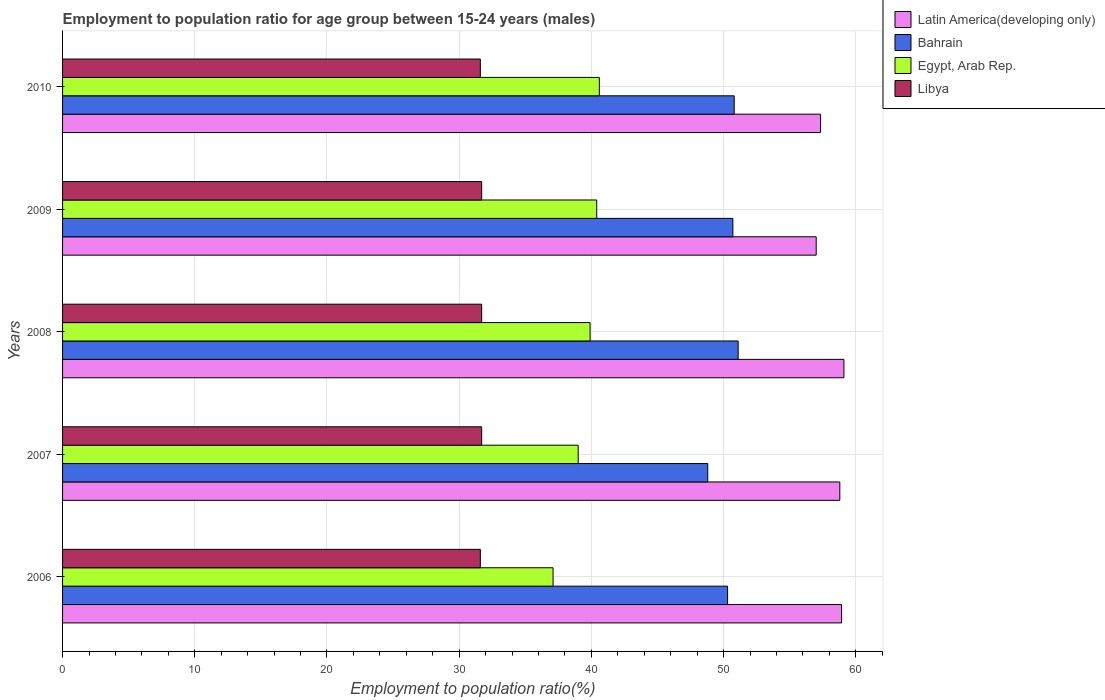How many different coloured bars are there?
Make the answer very short. 4. How many groups of bars are there?
Provide a succinct answer. 5. Are the number of bars per tick equal to the number of legend labels?
Offer a very short reply. Yes. What is the label of the 1st group of bars from the top?
Ensure brevity in your answer.  2010. In how many cases, is the number of bars for a given year not equal to the number of legend labels?
Make the answer very short. 0. What is the employment to population ratio in Latin America(developing only) in 2006?
Your response must be concise. 58.92. Across all years, what is the maximum employment to population ratio in Latin America(developing only)?
Provide a short and direct response. 59.1. Across all years, what is the minimum employment to population ratio in Libya?
Your answer should be compact. 31.6. What is the total employment to population ratio in Libya in the graph?
Your answer should be very brief. 158.3. What is the difference between the employment to population ratio in Bahrain in 2007 and that in 2008?
Keep it short and to the point. -2.3. What is the difference between the employment to population ratio in Egypt, Arab Rep. in 2006 and the employment to population ratio in Libya in 2007?
Offer a terse response. 5.4. What is the average employment to population ratio in Bahrain per year?
Make the answer very short. 50.34. In the year 2010, what is the difference between the employment to population ratio in Egypt, Arab Rep. and employment to population ratio in Bahrain?
Your answer should be very brief. -10.2. In how many years, is the employment to population ratio in Egypt, Arab Rep. greater than 12 %?
Offer a terse response. 5. What is the ratio of the employment to population ratio in Latin America(developing only) in 2009 to that in 2010?
Your response must be concise. 0.99. Is the employment to population ratio in Bahrain in 2006 less than that in 2008?
Your answer should be compact. Yes. Is the difference between the employment to population ratio in Egypt, Arab Rep. in 2006 and 2008 greater than the difference between the employment to population ratio in Bahrain in 2006 and 2008?
Provide a succinct answer. No. What is the difference between the highest and the second highest employment to population ratio in Bahrain?
Provide a short and direct response. 0.3. What is the difference between the highest and the lowest employment to population ratio in Bahrain?
Make the answer very short. 2.3. In how many years, is the employment to population ratio in Egypt, Arab Rep. greater than the average employment to population ratio in Egypt, Arab Rep. taken over all years?
Your answer should be very brief. 3. What does the 2nd bar from the top in 2006 represents?
Make the answer very short. Egypt, Arab Rep. What does the 2nd bar from the bottom in 2007 represents?
Ensure brevity in your answer.  Bahrain. How many bars are there?
Your answer should be very brief. 20. Are all the bars in the graph horizontal?
Your response must be concise. Yes. Are the values on the major ticks of X-axis written in scientific E-notation?
Keep it short and to the point. No. Does the graph contain any zero values?
Offer a terse response. No. Does the graph contain grids?
Your response must be concise. Yes. How many legend labels are there?
Make the answer very short. 4. How are the legend labels stacked?
Provide a succinct answer. Vertical. What is the title of the graph?
Provide a succinct answer. Employment to population ratio for age group between 15-24 years (males). Does "Portugal" appear as one of the legend labels in the graph?
Your response must be concise. No. What is the label or title of the X-axis?
Provide a succinct answer. Employment to population ratio(%). What is the Employment to population ratio(%) in Latin America(developing only) in 2006?
Make the answer very short. 58.92. What is the Employment to population ratio(%) in Bahrain in 2006?
Provide a short and direct response. 50.3. What is the Employment to population ratio(%) of Egypt, Arab Rep. in 2006?
Your answer should be very brief. 37.1. What is the Employment to population ratio(%) of Libya in 2006?
Ensure brevity in your answer.  31.6. What is the Employment to population ratio(%) in Latin America(developing only) in 2007?
Your answer should be very brief. 58.79. What is the Employment to population ratio(%) in Bahrain in 2007?
Offer a very short reply. 48.8. What is the Employment to population ratio(%) of Libya in 2007?
Offer a terse response. 31.7. What is the Employment to population ratio(%) of Latin America(developing only) in 2008?
Give a very brief answer. 59.1. What is the Employment to population ratio(%) in Bahrain in 2008?
Your response must be concise. 51.1. What is the Employment to population ratio(%) of Egypt, Arab Rep. in 2008?
Offer a very short reply. 39.9. What is the Employment to population ratio(%) of Libya in 2008?
Offer a very short reply. 31.7. What is the Employment to population ratio(%) of Latin America(developing only) in 2009?
Keep it short and to the point. 57. What is the Employment to population ratio(%) of Bahrain in 2009?
Provide a short and direct response. 50.7. What is the Employment to population ratio(%) in Egypt, Arab Rep. in 2009?
Offer a very short reply. 40.4. What is the Employment to population ratio(%) in Libya in 2009?
Keep it short and to the point. 31.7. What is the Employment to population ratio(%) of Latin America(developing only) in 2010?
Offer a terse response. 57.33. What is the Employment to population ratio(%) in Bahrain in 2010?
Your response must be concise. 50.8. What is the Employment to population ratio(%) of Egypt, Arab Rep. in 2010?
Ensure brevity in your answer.  40.6. What is the Employment to population ratio(%) in Libya in 2010?
Provide a succinct answer. 31.6. Across all years, what is the maximum Employment to population ratio(%) of Latin America(developing only)?
Keep it short and to the point. 59.1. Across all years, what is the maximum Employment to population ratio(%) in Bahrain?
Make the answer very short. 51.1. Across all years, what is the maximum Employment to population ratio(%) of Egypt, Arab Rep.?
Provide a short and direct response. 40.6. Across all years, what is the maximum Employment to population ratio(%) in Libya?
Offer a very short reply. 31.7. Across all years, what is the minimum Employment to population ratio(%) in Latin America(developing only)?
Your answer should be very brief. 57. Across all years, what is the minimum Employment to population ratio(%) in Bahrain?
Give a very brief answer. 48.8. Across all years, what is the minimum Employment to population ratio(%) in Egypt, Arab Rep.?
Make the answer very short. 37.1. Across all years, what is the minimum Employment to population ratio(%) of Libya?
Give a very brief answer. 31.6. What is the total Employment to population ratio(%) in Latin America(developing only) in the graph?
Provide a short and direct response. 291.14. What is the total Employment to population ratio(%) in Bahrain in the graph?
Make the answer very short. 251.7. What is the total Employment to population ratio(%) in Egypt, Arab Rep. in the graph?
Your response must be concise. 197. What is the total Employment to population ratio(%) of Libya in the graph?
Give a very brief answer. 158.3. What is the difference between the Employment to population ratio(%) in Latin America(developing only) in 2006 and that in 2007?
Your response must be concise. 0.13. What is the difference between the Employment to population ratio(%) of Latin America(developing only) in 2006 and that in 2008?
Your answer should be compact. -0.18. What is the difference between the Employment to population ratio(%) in Libya in 2006 and that in 2008?
Your response must be concise. -0.1. What is the difference between the Employment to population ratio(%) of Latin America(developing only) in 2006 and that in 2009?
Offer a very short reply. 1.92. What is the difference between the Employment to population ratio(%) of Bahrain in 2006 and that in 2009?
Provide a succinct answer. -0.4. What is the difference between the Employment to population ratio(%) of Latin America(developing only) in 2006 and that in 2010?
Offer a terse response. 1.59. What is the difference between the Employment to population ratio(%) in Libya in 2006 and that in 2010?
Provide a succinct answer. 0. What is the difference between the Employment to population ratio(%) in Latin America(developing only) in 2007 and that in 2008?
Make the answer very short. -0.31. What is the difference between the Employment to population ratio(%) of Latin America(developing only) in 2007 and that in 2009?
Make the answer very short. 1.79. What is the difference between the Employment to population ratio(%) of Egypt, Arab Rep. in 2007 and that in 2009?
Give a very brief answer. -1.4. What is the difference between the Employment to population ratio(%) in Libya in 2007 and that in 2009?
Provide a short and direct response. 0. What is the difference between the Employment to population ratio(%) of Latin America(developing only) in 2007 and that in 2010?
Your response must be concise. 1.46. What is the difference between the Employment to population ratio(%) of Libya in 2007 and that in 2010?
Provide a succinct answer. 0.1. What is the difference between the Employment to population ratio(%) in Latin America(developing only) in 2008 and that in 2009?
Ensure brevity in your answer.  2.1. What is the difference between the Employment to population ratio(%) in Egypt, Arab Rep. in 2008 and that in 2009?
Your response must be concise. -0.5. What is the difference between the Employment to population ratio(%) of Libya in 2008 and that in 2009?
Offer a very short reply. 0. What is the difference between the Employment to population ratio(%) of Latin America(developing only) in 2008 and that in 2010?
Make the answer very short. 1.77. What is the difference between the Employment to population ratio(%) of Latin America(developing only) in 2009 and that in 2010?
Your answer should be compact. -0.33. What is the difference between the Employment to population ratio(%) of Bahrain in 2009 and that in 2010?
Offer a very short reply. -0.1. What is the difference between the Employment to population ratio(%) in Egypt, Arab Rep. in 2009 and that in 2010?
Give a very brief answer. -0.2. What is the difference between the Employment to population ratio(%) in Libya in 2009 and that in 2010?
Offer a terse response. 0.1. What is the difference between the Employment to population ratio(%) in Latin America(developing only) in 2006 and the Employment to population ratio(%) in Bahrain in 2007?
Make the answer very short. 10.12. What is the difference between the Employment to population ratio(%) of Latin America(developing only) in 2006 and the Employment to population ratio(%) of Egypt, Arab Rep. in 2007?
Your answer should be very brief. 19.92. What is the difference between the Employment to population ratio(%) of Latin America(developing only) in 2006 and the Employment to population ratio(%) of Libya in 2007?
Your response must be concise. 27.22. What is the difference between the Employment to population ratio(%) of Bahrain in 2006 and the Employment to population ratio(%) of Egypt, Arab Rep. in 2007?
Keep it short and to the point. 11.3. What is the difference between the Employment to population ratio(%) in Bahrain in 2006 and the Employment to population ratio(%) in Libya in 2007?
Your response must be concise. 18.6. What is the difference between the Employment to population ratio(%) of Egypt, Arab Rep. in 2006 and the Employment to population ratio(%) of Libya in 2007?
Give a very brief answer. 5.4. What is the difference between the Employment to population ratio(%) of Latin America(developing only) in 2006 and the Employment to population ratio(%) of Bahrain in 2008?
Make the answer very short. 7.82. What is the difference between the Employment to population ratio(%) in Latin America(developing only) in 2006 and the Employment to population ratio(%) in Egypt, Arab Rep. in 2008?
Provide a short and direct response. 19.02. What is the difference between the Employment to population ratio(%) of Latin America(developing only) in 2006 and the Employment to population ratio(%) of Libya in 2008?
Provide a short and direct response. 27.22. What is the difference between the Employment to population ratio(%) in Bahrain in 2006 and the Employment to population ratio(%) in Egypt, Arab Rep. in 2008?
Offer a terse response. 10.4. What is the difference between the Employment to population ratio(%) of Bahrain in 2006 and the Employment to population ratio(%) of Libya in 2008?
Provide a succinct answer. 18.6. What is the difference between the Employment to population ratio(%) of Latin America(developing only) in 2006 and the Employment to population ratio(%) of Bahrain in 2009?
Give a very brief answer. 8.22. What is the difference between the Employment to population ratio(%) in Latin America(developing only) in 2006 and the Employment to population ratio(%) in Egypt, Arab Rep. in 2009?
Offer a very short reply. 18.52. What is the difference between the Employment to population ratio(%) in Latin America(developing only) in 2006 and the Employment to population ratio(%) in Libya in 2009?
Make the answer very short. 27.22. What is the difference between the Employment to population ratio(%) in Bahrain in 2006 and the Employment to population ratio(%) in Egypt, Arab Rep. in 2009?
Your answer should be compact. 9.9. What is the difference between the Employment to population ratio(%) of Latin America(developing only) in 2006 and the Employment to population ratio(%) of Bahrain in 2010?
Provide a short and direct response. 8.12. What is the difference between the Employment to population ratio(%) in Latin America(developing only) in 2006 and the Employment to population ratio(%) in Egypt, Arab Rep. in 2010?
Provide a succinct answer. 18.32. What is the difference between the Employment to population ratio(%) in Latin America(developing only) in 2006 and the Employment to population ratio(%) in Libya in 2010?
Your response must be concise. 27.32. What is the difference between the Employment to population ratio(%) in Bahrain in 2006 and the Employment to population ratio(%) in Egypt, Arab Rep. in 2010?
Offer a terse response. 9.7. What is the difference between the Employment to population ratio(%) in Bahrain in 2006 and the Employment to population ratio(%) in Libya in 2010?
Make the answer very short. 18.7. What is the difference between the Employment to population ratio(%) of Latin America(developing only) in 2007 and the Employment to population ratio(%) of Bahrain in 2008?
Make the answer very short. 7.69. What is the difference between the Employment to population ratio(%) of Latin America(developing only) in 2007 and the Employment to population ratio(%) of Egypt, Arab Rep. in 2008?
Provide a short and direct response. 18.89. What is the difference between the Employment to population ratio(%) of Latin America(developing only) in 2007 and the Employment to population ratio(%) of Libya in 2008?
Offer a terse response. 27.09. What is the difference between the Employment to population ratio(%) in Bahrain in 2007 and the Employment to population ratio(%) in Libya in 2008?
Provide a short and direct response. 17.1. What is the difference between the Employment to population ratio(%) in Latin America(developing only) in 2007 and the Employment to population ratio(%) in Bahrain in 2009?
Offer a terse response. 8.09. What is the difference between the Employment to population ratio(%) of Latin America(developing only) in 2007 and the Employment to population ratio(%) of Egypt, Arab Rep. in 2009?
Offer a very short reply. 18.39. What is the difference between the Employment to population ratio(%) in Latin America(developing only) in 2007 and the Employment to population ratio(%) in Libya in 2009?
Your answer should be compact. 27.09. What is the difference between the Employment to population ratio(%) of Bahrain in 2007 and the Employment to population ratio(%) of Egypt, Arab Rep. in 2009?
Your answer should be very brief. 8.4. What is the difference between the Employment to population ratio(%) in Latin America(developing only) in 2007 and the Employment to population ratio(%) in Bahrain in 2010?
Provide a short and direct response. 7.99. What is the difference between the Employment to population ratio(%) of Latin America(developing only) in 2007 and the Employment to population ratio(%) of Egypt, Arab Rep. in 2010?
Provide a short and direct response. 18.19. What is the difference between the Employment to population ratio(%) in Latin America(developing only) in 2007 and the Employment to population ratio(%) in Libya in 2010?
Your response must be concise. 27.19. What is the difference between the Employment to population ratio(%) in Bahrain in 2007 and the Employment to population ratio(%) in Libya in 2010?
Provide a succinct answer. 17.2. What is the difference between the Employment to population ratio(%) in Latin America(developing only) in 2008 and the Employment to population ratio(%) in Bahrain in 2009?
Offer a very short reply. 8.4. What is the difference between the Employment to population ratio(%) in Latin America(developing only) in 2008 and the Employment to population ratio(%) in Egypt, Arab Rep. in 2009?
Provide a succinct answer. 18.7. What is the difference between the Employment to population ratio(%) of Latin America(developing only) in 2008 and the Employment to population ratio(%) of Libya in 2009?
Ensure brevity in your answer.  27.4. What is the difference between the Employment to population ratio(%) of Bahrain in 2008 and the Employment to population ratio(%) of Egypt, Arab Rep. in 2009?
Offer a terse response. 10.7. What is the difference between the Employment to population ratio(%) in Bahrain in 2008 and the Employment to population ratio(%) in Libya in 2009?
Give a very brief answer. 19.4. What is the difference between the Employment to population ratio(%) in Egypt, Arab Rep. in 2008 and the Employment to population ratio(%) in Libya in 2009?
Your answer should be very brief. 8.2. What is the difference between the Employment to population ratio(%) of Latin America(developing only) in 2008 and the Employment to population ratio(%) of Bahrain in 2010?
Provide a succinct answer. 8.3. What is the difference between the Employment to population ratio(%) of Latin America(developing only) in 2008 and the Employment to population ratio(%) of Egypt, Arab Rep. in 2010?
Keep it short and to the point. 18.5. What is the difference between the Employment to population ratio(%) of Latin America(developing only) in 2008 and the Employment to population ratio(%) of Libya in 2010?
Make the answer very short. 27.5. What is the difference between the Employment to population ratio(%) in Egypt, Arab Rep. in 2008 and the Employment to population ratio(%) in Libya in 2010?
Offer a very short reply. 8.3. What is the difference between the Employment to population ratio(%) of Latin America(developing only) in 2009 and the Employment to population ratio(%) of Bahrain in 2010?
Make the answer very short. 6.2. What is the difference between the Employment to population ratio(%) of Latin America(developing only) in 2009 and the Employment to population ratio(%) of Egypt, Arab Rep. in 2010?
Ensure brevity in your answer.  16.4. What is the difference between the Employment to population ratio(%) of Latin America(developing only) in 2009 and the Employment to population ratio(%) of Libya in 2010?
Give a very brief answer. 25.4. What is the difference between the Employment to population ratio(%) of Bahrain in 2009 and the Employment to population ratio(%) of Egypt, Arab Rep. in 2010?
Offer a terse response. 10.1. What is the difference between the Employment to population ratio(%) of Bahrain in 2009 and the Employment to population ratio(%) of Libya in 2010?
Your response must be concise. 19.1. What is the difference between the Employment to population ratio(%) of Egypt, Arab Rep. in 2009 and the Employment to population ratio(%) of Libya in 2010?
Your response must be concise. 8.8. What is the average Employment to population ratio(%) in Latin America(developing only) per year?
Make the answer very short. 58.23. What is the average Employment to population ratio(%) of Bahrain per year?
Provide a succinct answer. 50.34. What is the average Employment to population ratio(%) of Egypt, Arab Rep. per year?
Provide a succinct answer. 39.4. What is the average Employment to population ratio(%) in Libya per year?
Give a very brief answer. 31.66. In the year 2006, what is the difference between the Employment to population ratio(%) in Latin America(developing only) and Employment to population ratio(%) in Bahrain?
Offer a very short reply. 8.62. In the year 2006, what is the difference between the Employment to population ratio(%) in Latin America(developing only) and Employment to population ratio(%) in Egypt, Arab Rep.?
Keep it short and to the point. 21.82. In the year 2006, what is the difference between the Employment to population ratio(%) of Latin America(developing only) and Employment to population ratio(%) of Libya?
Your answer should be compact. 27.32. In the year 2007, what is the difference between the Employment to population ratio(%) of Latin America(developing only) and Employment to population ratio(%) of Bahrain?
Your response must be concise. 9.99. In the year 2007, what is the difference between the Employment to population ratio(%) in Latin America(developing only) and Employment to population ratio(%) in Egypt, Arab Rep.?
Your answer should be compact. 19.79. In the year 2007, what is the difference between the Employment to population ratio(%) of Latin America(developing only) and Employment to population ratio(%) of Libya?
Your answer should be compact. 27.09. In the year 2007, what is the difference between the Employment to population ratio(%) in Bahrain and Employment to population ratio(%) in Egypt, Arab Rep.?
Ensure brevity in your answer.  9.8. In the year 2008, what is the difference between the Employment to population ratio(%) of Latin America(developing only) and Employment to population ratio(%) of Bahrain?
Your answer should be compact. 8. In the year 2008, what is the difference between the Employment to population ratio(%) of Latin America(developing only) and Employment to population ratio(%) of Egypt, Arab Rep.?
Make the answer very short. 19.2. In the year 2008, what is the difference between the Employment to population ratio(%) of Latin America(developing only) and Employment to population ratio(%) of Libya?
Your answer should be very brief. 27.4. In the year 2009, what is the difference between the Employment to population ratio(%) of Latin America(developing only) and Employment to population ratio(%) of Bahrain?
Make the answer very short. 6.3. In the year 2009, what is the difference between the Employment to population ratio(%) of Latin America(developing only) and Employment to population ratio(%) of Egypt, Arab Rep.?
Offer a very short reply. 16.6. In the year 2009, what is the difference between the Employment to population ratio(%) in Latin America(developing only) and Employment to population ratio(%) in Libya?
Provide a short and direct response. 25.3. In the year 2009, what is the difference between the Employment to population ratio(%) in Bahrain and Employment to population ratio(%) in Libya?
Your answer should be compact. 19. In the year 2010, what is the difference between the Employment to population ratio(%) in Latin America(developing only) and Employment to population ratio(%) in Bahrain?
Make the answer very short. 6.53. In the year 2010, what is the difference between the Employment to population ratio(%) in Latin America(developing only) and Employment to population ratio(%) in Egypt, Arab Rep.?
Make the answer very short. 16.73. In the year 2010, what is the difference between the Employment to population ratio(%) of Latin America(developing only) and Employment to population ratio(%) of Libya?
Make the answer very short. 25.73. In the year 2010, what is the difference between the Employment to population ratio(%) of Bahrain and Employment to population ratio(%) of Egypt, Arab Rep.?
Offer a very short reply. 10.2. In the year 2010, what is the difference between the Employment to population ratio(%) of Egypt, Arab Rep. and Employment to population ratio(%) of Libya?
Make the answer very short. 9. What is the ratio of the Employment to population ratio(%) of Latin America(developing only) in 2006 to that in 2007?
Keep it short and to the point. 1. What is the ratio of the Employment to population ratio(%) in Bahrain in 2006 to that in 2007?
Your answer should be very brief. 1.03. What is the ratio of the Employment to population ratio(%) of Egypt, Arab Rep. in 2006 to that in 2007?
Keep it short and to the point. 0.95. What is the ratio of the Employment to population ratio(%) in Latin America(developing only) in 2006 to that in 2008?
Your answer should be very brief. 1. What is the ratio of the Employment to population ratio(%) in Bahrain in 2006 to that in 2008?
Make the answer very short. 0.98. What is the ratio of the Employment to population ratio(%) of Egypt, Arab Rep. in 2006 to that in 2008?
Your response must be concise. 0.93. What is the ratio of the Employment to population ratio(%) in Libya in 2006 to that in 2008?
Your response must be concise. 1. What is the ratio of the Employment to population ratio(%) of Latin America(developing only) in 2006 to that in 2009?
Your answer should be very brief. 1.03. What is the ratio of the Employment to population ratio(%) in Egypt, Arab Rep. in 2006 to that in 2009?
Offer a terse response. 0.92. What is the ratio of the Employment to population ratio(%) in Latin America(developing only) in 2006 to that in 2010?
Provide a short and direct response. 1.03. What is the ratio of the Employment to population ratio(%) of Bahrain in 2006 to that in 2010?
Your answer should be compact. 0.99. What is the ratio of the Employment to population ratio(%) in Egypt, Arab Rep. in 2006 to that in 2010?
Keep it short and to the point. 0.91. What is the ratio of the Employment to population ratio(%) in Libya in 2006 to that in 2010?
Your answer should be very brief. 1. What is the ratio of the Employment to population ratio(%) of Bahrain in 2007 to that in 2008?
Provide a succinct answer. 0.95. What is the ratio of the Employment to population ratio(%) in Egypt, Arab Rep. in 2007 to that in 2008?
Give a very brief answer. 0.98. What is the ratio of the Employment to population ratio(%) in Latin America(developing only) in 2007 to that in 2009?
Your answer should be very brief. 1.03. What is the ratio of the Employment to population ratio(%) of Bahrain in 2007 to that in 2009?
Ensure brevity in your answer.  0.96. What is the ratio of the Employment to population ratio(%) in Egypt, Arab Rep. in 2007 to that in 2009?
Provide a succinct answer. 0.97. What is the ratio of the Employment to population ratio(%) of Libya in 2007 to that in 2009?
Offer a very short reply. 1. What is the ratio of the Employment to population ratio(%) of Latin America(developing only) in 2007 to that in 2010?
Offer a very short reply. 1.03. What is the ratio of the Employment to population ratio(%) of Bahrain in 2007 to that in 2010?
Make the answer very short. 0.96. What is the ratio of the Employment to population ratio(%) of Egypt, Arab Rep. in 2007 to that in 2010?
Give a very brief answer. 0.96. What is the ratio of the Employment to population ratio(%) of Libya in 2007 to that in 2010?
Your answer should be very brief. 1. What is the ratio of the Employment to population ratio(%) of Latin America(developing only) in 2008 to that in 2009?
Keep it short and to the point. 1.04. What is the ratio of the Employment to population ratio(%) of Bahrain in 2008 to that in 2009?
Offer a very short reply. 1.01. What is the ratio of the Employment to population ratio(%) in Egypt, Arab Rep. in 2008 to that in 2009?
Ensure brevity in your answer.  0.99. What is the ratio of the Employment to population ratio(%) in Latin America(developing only) in 2008 to that in 2010?
Provide a short and direct response. 1.03. What is the ratio of the Employment to population ratio(%) in Bahrain in 2008 to that in 2010?
Your response must be concise. 1.01. What is the ratio of the Employment to population ratio(%) of Egypt, Arab Rep. in 2008 to that in 2010?
Make the answer very short. 0.98. What is the ratio of the Employment to population ratio(%) of Libya in 2008 to that in 2010?
Your response must be concise. 1. What is the ratio of the Employment to population ratio(%) in Latin America(developing only) in 2009 to that in 2010?
Give a very brief answer. 0.99. What is the ratio of the Employment to population ratio(%) of Bahrain in 2009 to that in 2010?
Make the answer very short. 1. What is the ratio of the Employment to population ratio(%) of Libya in 2009 to that in 2010?
Provide a short and direct response. 1. What is the difference between the highest and the second highest Employment to population ratio(%) in Latin America(developing only)?
Ensure brevity in your answer.  0.18. What is the difference between the highest and the second highest Employment to population ratio(%) in Bahrain?
Provide a succinct answer. 0.3. What is the difference between the highest and the second highest Employment to population ratio(%) in Libya?
Keep it short and to the point. 0. What is the difference between the highest and the lowest Employment to population ratio(%) in Latin America(developing only)?
Make the answer very short. 2.1. What is the difference between the highest and the lowest Employment to population ratio(%) in Libya?
Offer a terse response. 0.1. 